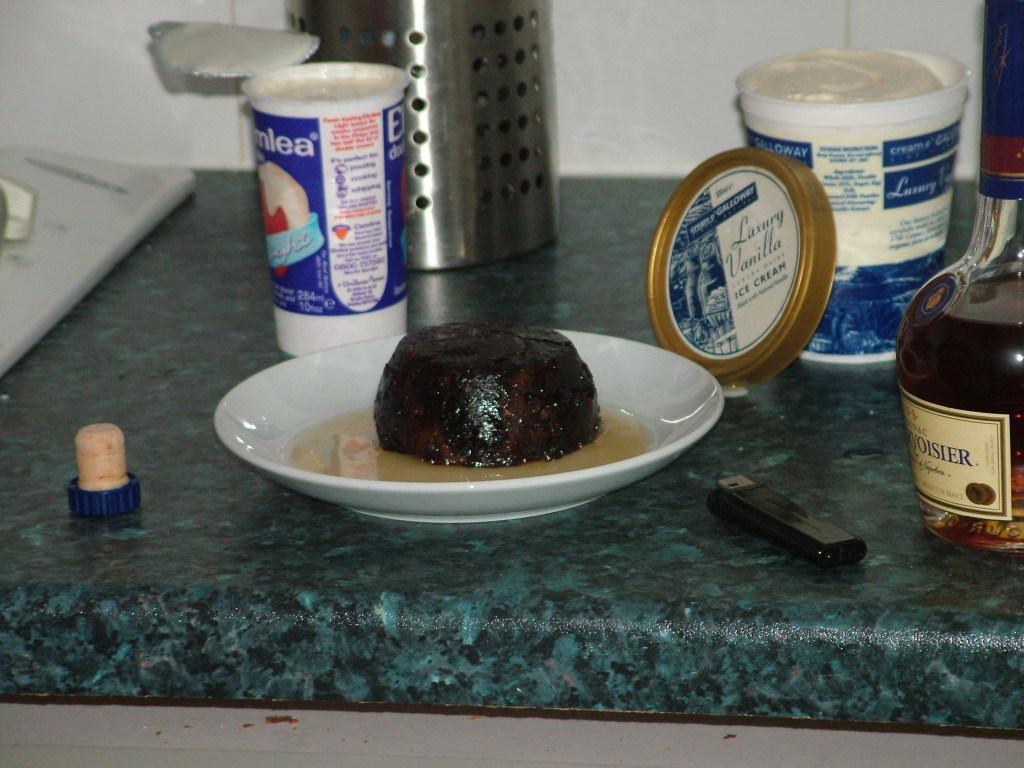What kind of ice cream is in the container?
Offer a terse response. Vanilla. 